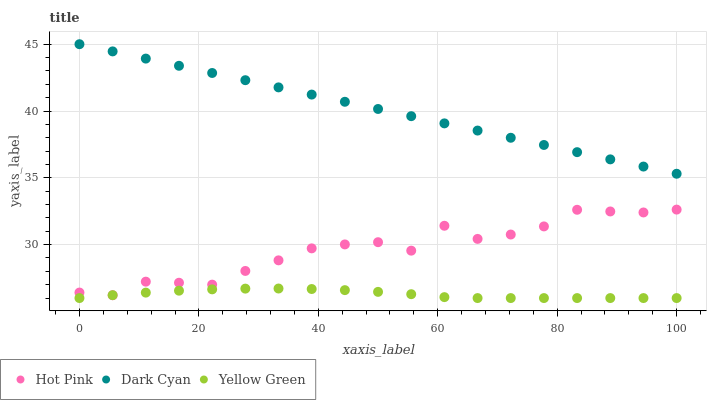Does Yellow Green have the minimum area under the curve?
Answer yes or no. Yes. Does Dark Cyan have the maximum area under the curve?
Answer yes or no. Yes. Does Hot Pink have the minimum area under the curve?
Answer yes or no. No. Does Hot Pink have the maximum area under the curve?
Answer yes or no. No. Is Dark Cyan the smoothest?
Answer yes or no. Yes. Is Hot Pink the roughest?
Answer yes or no. Yes. Is Yellow Green the smoothest?
Answer yes or no. No. Is Yellow Green the roughest?
Answer yes or no. No. Does Yellow Green have the lowest value?
Answer yes or no. Yes. Does Hot Pink have the lowest value?
Answer yes or no. No. Does Dark Cyan have the highest value?
Answer yes or no. Yes. Does Hot Pink have the highest value?
Answer yes or no. No. Is Hot Pink less than Dark Cyan?
Answer yes or no. Yes. Is Dark Cyan greater than Hot Pink?
Answer yes or no. Yes. Does Yellow Green intersect Hot Pink?
Answer yes or no. Yes. Is Yellow Green less than Hot Pink?
Answer yes or no. No. Is Yellow Green greater than Hot Pink?
Answer yes or no. No. Does Hot Pink intersect Dark Cyan?
Answer yes or no. No. 